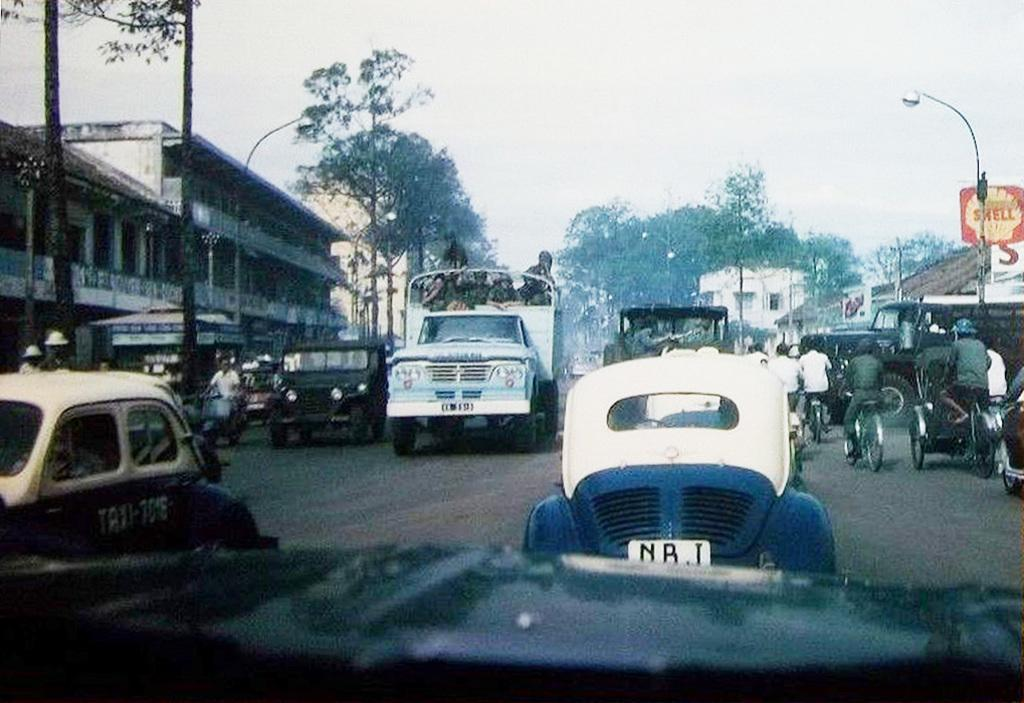What is present on the road in the image? There are vehicles on the road in the image. What can be seen in the distance behind the vehicles? There are buildings, trees, street lights, and the sky visible in the background of the image. Can you see a snake slithering under the street lights in the image? There is no snake present in the image; it only features vehicles on the road, buildings, trees, street lights, and the sky in the background. 